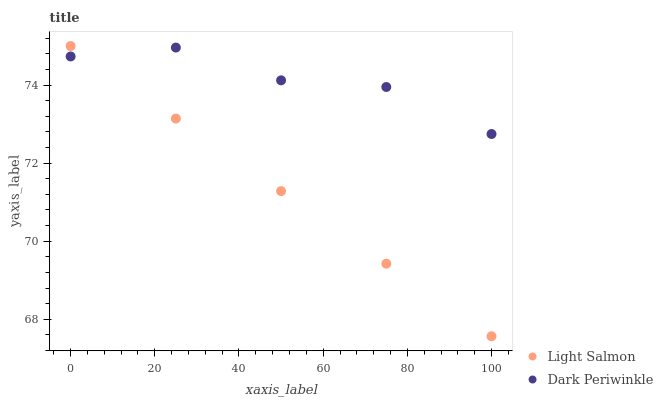Does Light Salmon have the minimum area under the curve?
Answer yes or no. Yes. Does Dark Periwinkle have the maximum area under the curve?
Answer yes or no. Yes. Does Dark Periwinkle have the minimum area under the curve?
Answer yes or no. No. Is Light Salmon the smoothest?
Answer yes or no. Yes. Is Dark Periwinkle the roughest?
Answer yes or no. Yes. Is Dark Periwinkle the smoothest?
Answer yes or no. No. Does Light Salmon have the lowest value?
Answer yes or no. Yes. Does Dark Periwinkle have the lowest value?
Answer yes or no. No. Does Light Salmon have the highest value?
Answer yes or no. Yes. Does Dark Periwinkle have the highest value?
Answer yes or no. No. Does Light Salmon intersect Dark Periwinkle?
Answer yes or no. Yes. Is Light Salmon less than Dark Periwinkle?
Answer yes or no. No. Is Light Salmon greater than Dark Periwinkle?
Answer yes or no. No. 